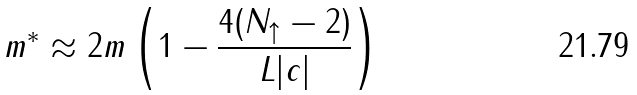<formula> <loc_0><loc_0><loc_500><loc_500>m ^ { * } \approx 2 m \left ( 1 - \frac { 4 ( N _ { \uparrow } - 2 ) } { L | c | } \right )</formula> 